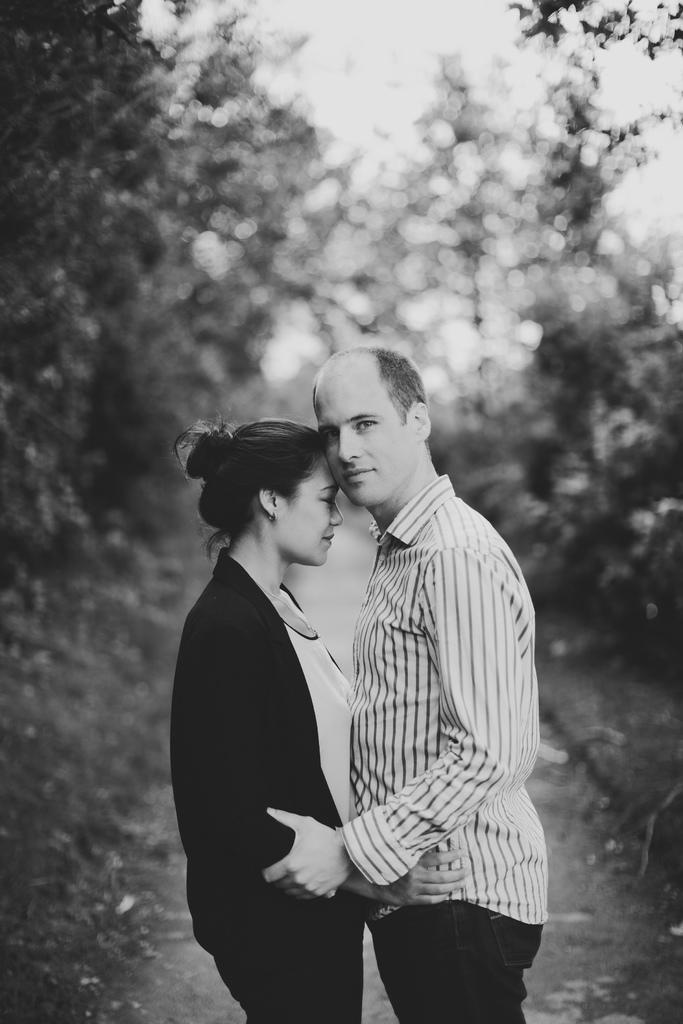What is the color scheme of the image? The image is in black and white. What can be seen on the land in the image? There is a woman standing on the land. Who is supporting the woman in the image? There is a person holding the woman's hand. What type of vegetation is visible in the background of the image? There are trees in the background. What is visible at the top of the image? The sky is visible at the top of the image. Can you see any bees buzzing around the woman in the image? There are no bees present in the image. What type of stick is the woman using to walk in the image? There is no stick visible in the image. 